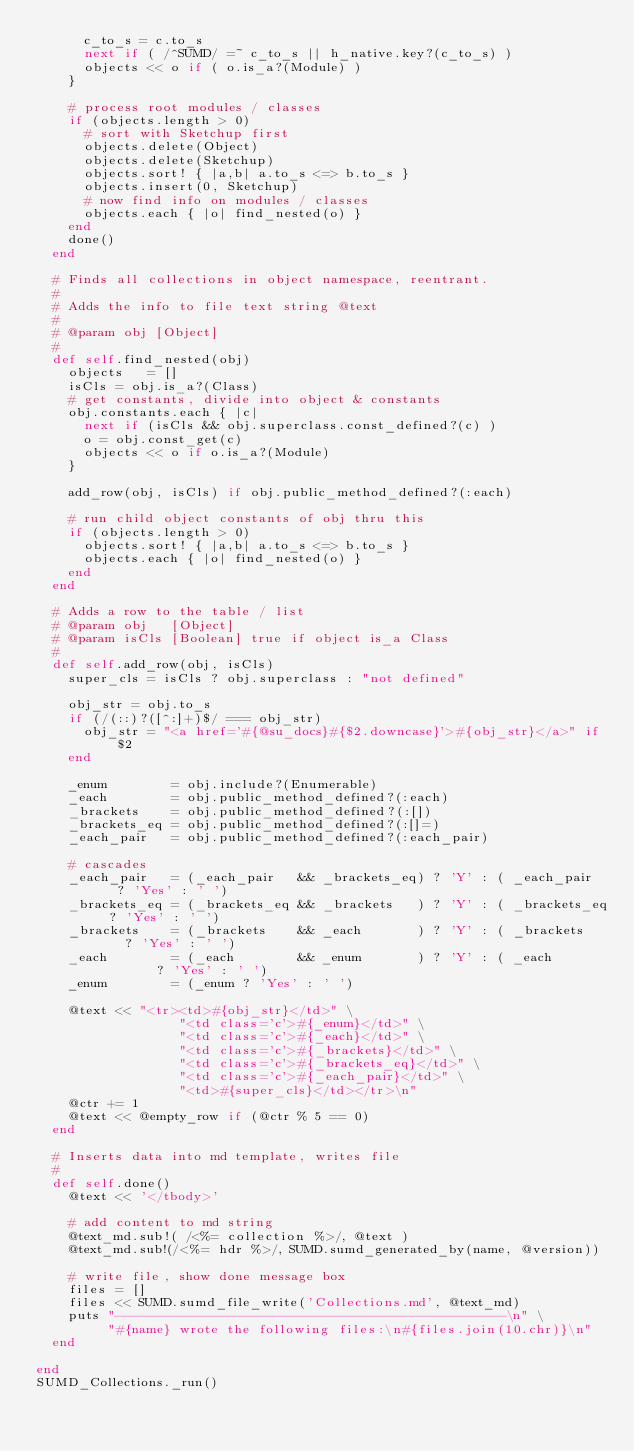Convert code to text. <code><loc_0><loc_0><loc_500><loc_500><_Ruby_>      c_to_s = c.to_s
      next if ( /^SUMD/ =~ c_to_s || h_native.key?(c_to_s) )
      objects << o if ( o.is_a?(Module) )
    }

    # process root modules / classes
    if (objects.length > 0)
      # sort with Sketchup first
      objects.delete(Object)
      objects.delete(Sketchup)
      objects.sort! { |a,b| a.to_s <=> b.to_s }
      objects.insert(0, Sketchup)
      # now find info on modules / classes
      objects.each { |o| find_nested(o) }
    end
    done()
  end

  # Finds all collections in object namespace, reentrant.
  #
  # Adds the info to file text string @text
  #
  # @param obj [Object]
  #
	def self.find_nested(obj)
    objects   = []
    isCls = obj.is_a?(Class)
    # get constants, divide into object & constants
    obj.constants.each { |c|
      next if (isCls && obj.superclass.const_defined?(c) )
      o = obj.const_get(c)
      objects << o if o.is_a?(Module)
    }

    add_row(obj, isCls) if obj.public_method_defined?(:each)

    # run child object constants of obj thru this
    if (objects.length > 0)
      objects.sort! { |a,b| a.to_s <=> b.to_s }
      objects.each { |o| find_nested(o) }
    end
	end

  # Adds a row to the table / list
  # @param obj   [Object]
  # @param isCls [Boolean] true if object is_a Class
  #
  def self.add_row(obj, isCls)
    super_cls = isCls ? obj.superclass : "not defined"

    obj_str = obj.to_s
    if (/(::)?([^:]+)$/ === obj_str)
      obj_str = "<a href='#{@su_docs}#{$2.downcase}'>#{obj_str}</a>" if $2
    end

    _enum        = obj.include?(Enumerable)
    _each        = obj.public_method_defined?(:each)
    _brackets    = obj.public_method_defined?(:[])
    _brackets_eq = obj.public_method_defined?(:[]=)
    _each_pair   = obj.public_method_defined?(:each_pair)

    # cascades
    _each_pair   = (_each_pair   && _brackets_eq) ? 'Y' : ( _each_pair   ? 'Yes' : ' ')
    _brackets_eq = (_brackets_eq && _brackets   ) ? 'Y' : ( _brackets_eq ? 'Yes' : ' ')
    _brackets    = (_brackets    && _each       ) ? 'Y' : ( _brackets    ? 'Yes' : ' ')
    _each        = (_each        && _enum       ) ? 'Y' : ( _each        ? 'Yes' : ' ')
    _enum        = (_enum ? 'Yes' : ' ')

    @text << "<tr><td>#{obj_str}</td>" \
                  "<td class='c'>#{_enum}</td>" \
                  "<td class='c'>#{_each}</td>" \
                  "<td class='c'>#{_brackets}</td>" \
                  "<td class='c'>#{_brackets_eq}</td>" \
                  "<td class='c'>#{_each_pair}</td>" \
                  "<td>#{super_cls}</td></tr>\n"
    @ctr += 1
    @text << @empty_row if (@ctr % 5 == 0)
  end

  # Inserts data into md template, writes file
  #
  def self.done()
    @text << '</tbody>'

    # add content to md string
    @text_md.sub!( /<%= collection %>/, @text )
    @text_md.sub!(/<%= hdr %>/, SUMD.sumd_generated_by(name, @version))

    # write file, show done message box
    files = []
    files << SUMD.sumd_file_write('Collections.md', @text_md)
    puts "-------------------------------------------------\n" \
         "#{name} wrote the following files:\n#{files.join(10.chr)}\n"
  end

end
SUMD_Collections._run()

</code> 